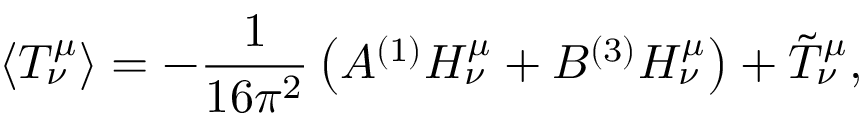<formula> <loc_0><loc_0><loc_500><loc_500>\langle T _ { \nu } ^ { \mu } \rangle = - { \frac { 1 } { 1 6 \pi ^ { 2 } } } \left ( ^ { ( 1 ) } H _ { \nu } ^ { \mu } + ^ { ( 3 ) } H _ { \nu } ^ { \mu } \right ) + \tilde { T } _ { \nu } ^ { \mu } ,</formula> 